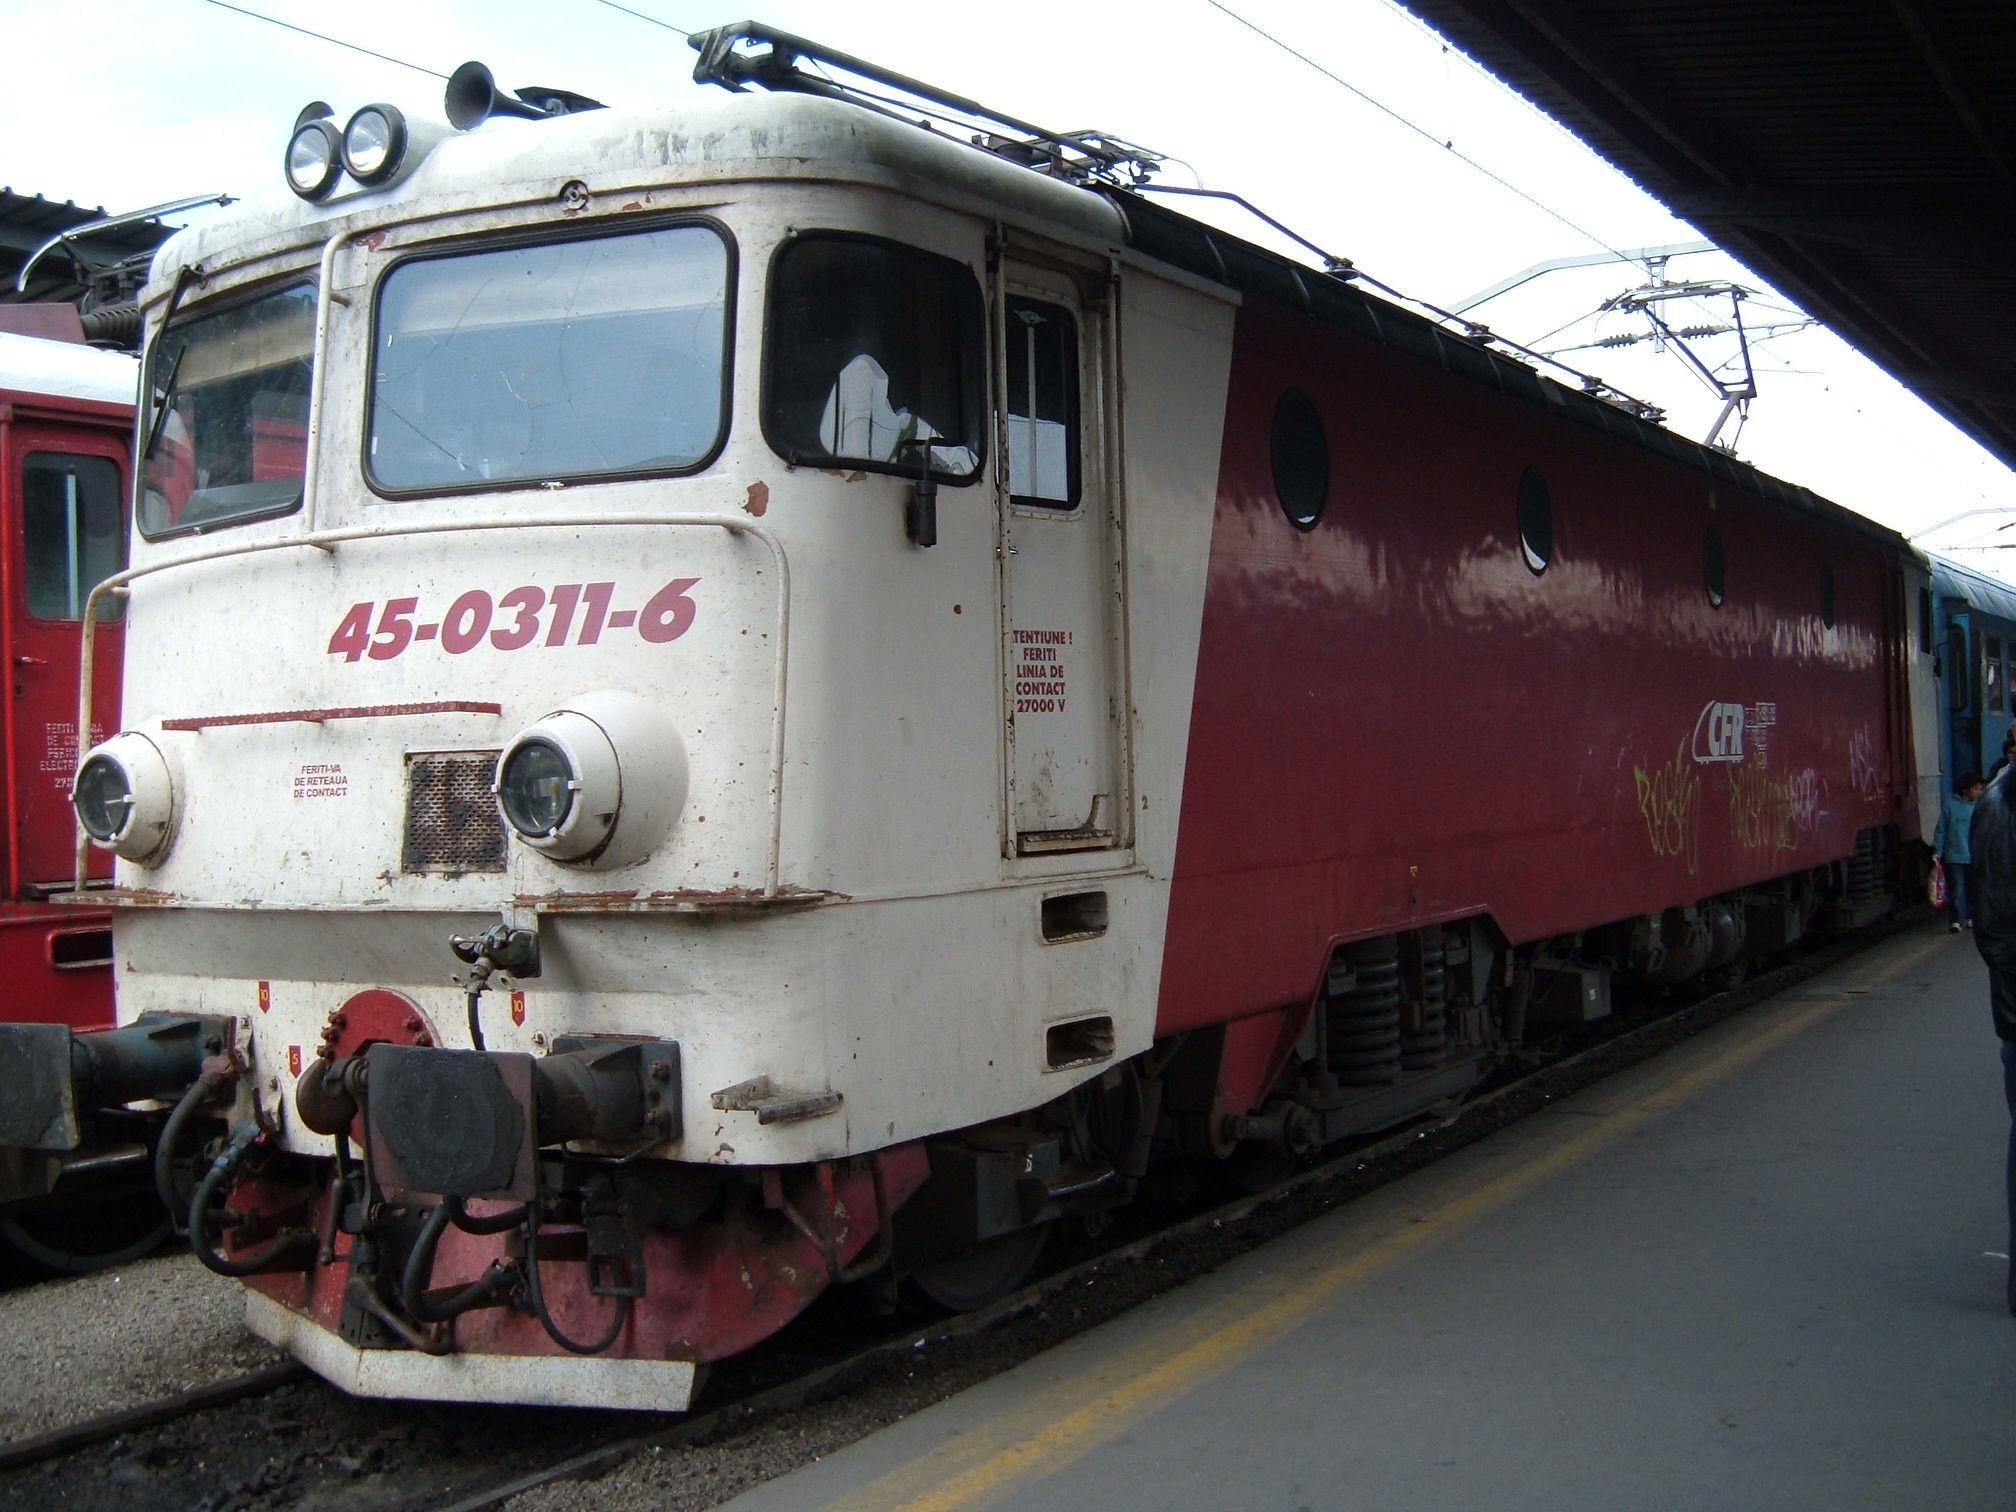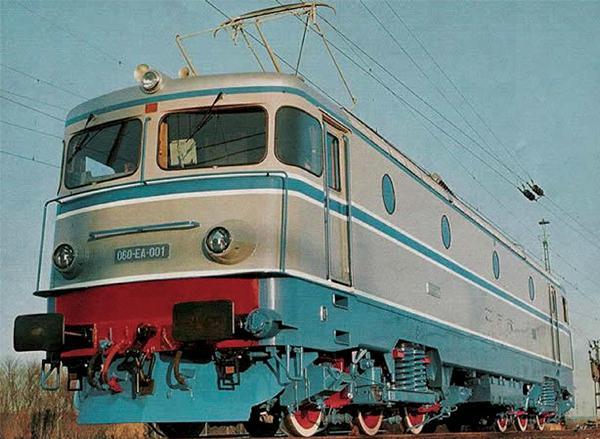The first image is the image on the left, the second image is the image on the right. Considering the images on both sides, is "One image shows a red and white train angled to face leftward." valid? Answer yes or no. Yes. 